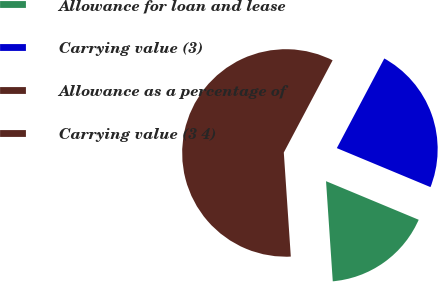Convert chart to OTSL. <chart><loc_0><loc_0><loc_500><loc_500><pie_chart><fcel>Allowance for loan and lease<fcel>Carrying value (3)<fcel>Allowance as a percentage of<fcel>Carrying value (3 4)<nl><fcel>17.65%<fcel>23.53%<fcel>0.0%<fcel>58.82%<nl></chart> 